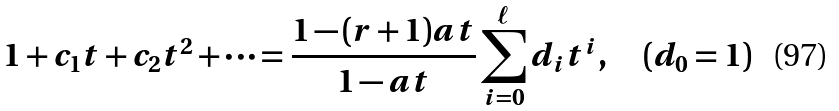<formula> <loc_0><loc_0><loc_500><loc_500>1 + c _ { 1 } t + c _ { 2 } t ^ { 2 } + \dots = \frac { 1 - ( r + 1 ) a t } { 1 - a t } \sum _ { i = 0 } ^ { \ell } d _ { i } t ^ { i } , \quad ( d _ { 0 } = 1 )</formula> 